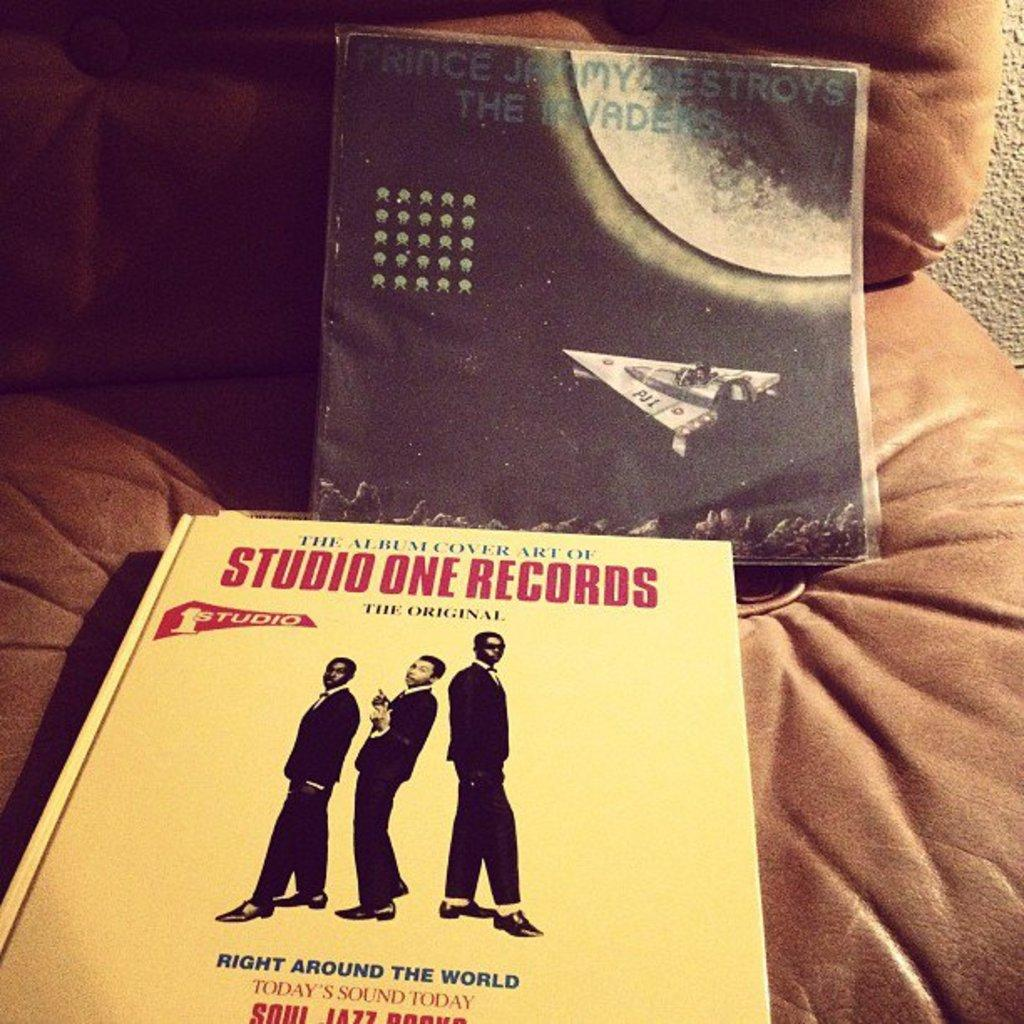<image>
Write a terse but informative summary of the picture. A book about album cover art and a Prince Jammy record sit on a chair. 